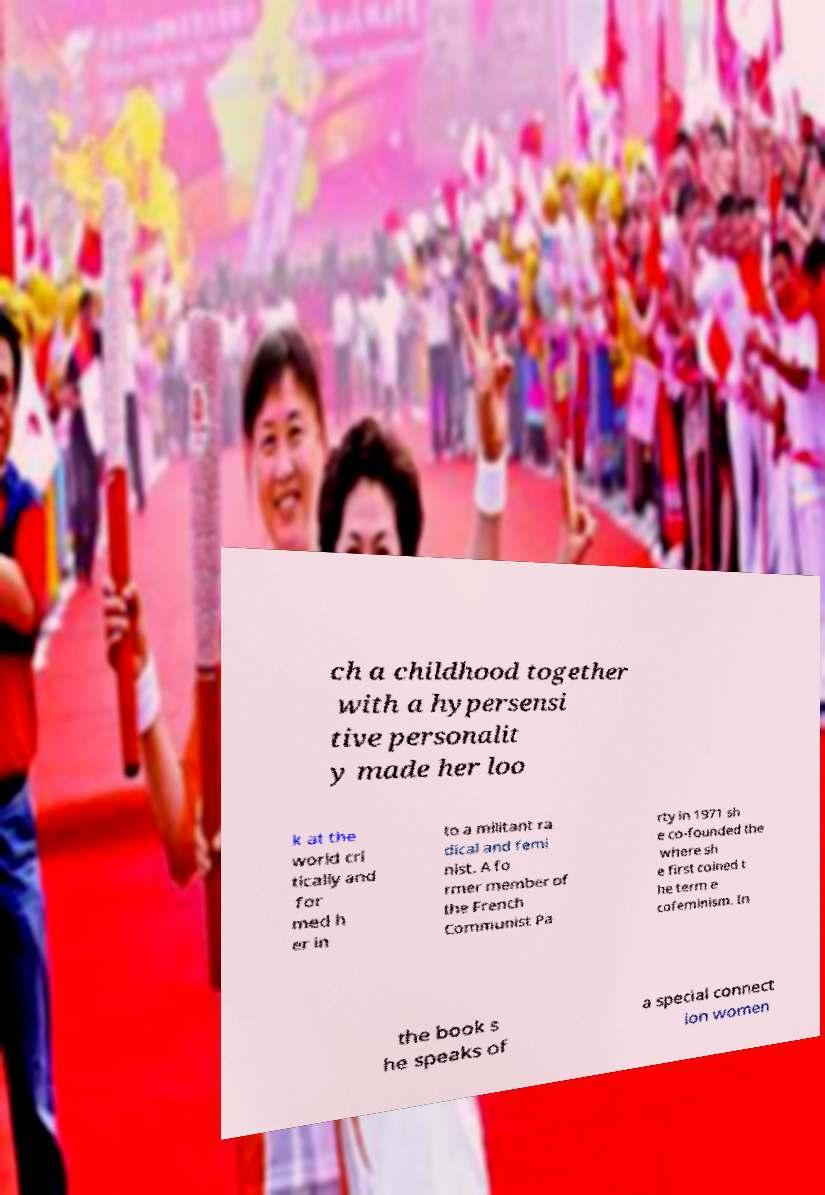For documentation purposes, I need the text within this image transcribed. Could you provide that? ch a childhood together with a hypersensi tive personalit y made her loo k at the world cri tically and for med h er in to a militant ra dical and femi nist. A fo rmer member of the French Communist Pa rty in 1971 sh e co-founded the where sh e first coined t he term e cofeminism. In the book s he speaks of a special connect ion women 